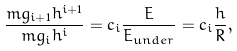Convert formula to latex. <formula><loc_0><loc_0><loc_500><loc_500>\frac { m g _ { i + 1 } h ^ { i + 1 } } { m g _ { i } h ^ { i } } = c _ { i } \frac { E } { E _ { u n d e r } } = c _ { i } \frac { h } { R } ,</formula> 